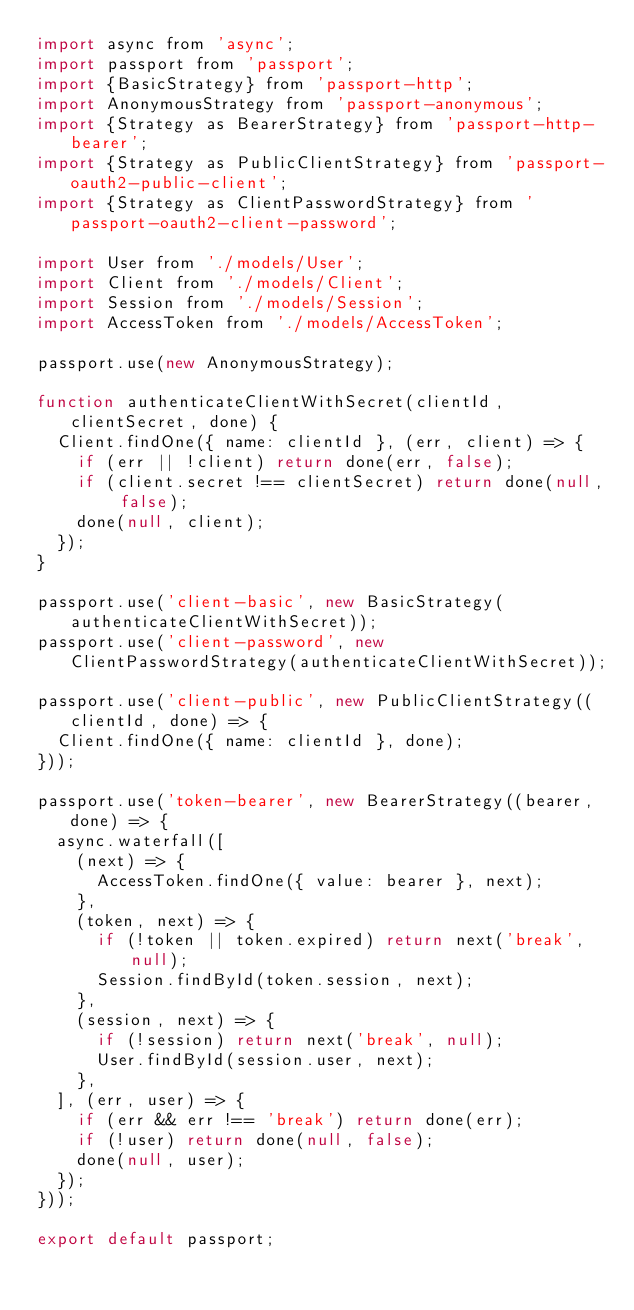Convert code to text. <code><loc_0><loc_0><loc_500><loc_500><_JavaScript_>import async from 'async';
import passport from 'passport';
import {BasicStrategy} from 'passport-http';
import AnonymousStrategy from 'passport-anonymous';
import {Strategy as BearerStrategy} from 'passport-http-bearer';
import {Strategy as PublicClientStrategy} from 'passport-oauth2-public-client';
import {Strategy as ClientPasswordStrategy} from 'passport-oauth2-client-password';

import User from './models/User';
import Client from './models/Client';
import Session from './models/Session';
import AccessToken from './models/AccessToken';

passport.use(new AnonymousStrategy);

function authenticateClientWithSecret(clientId, clientSecret, done) {
	Client.findOne({ name: clientId }, (err, client) => {
		if (err || !client) return done(err, false);
		if (client.secret !== clientSecret) return done(null, false);
		done(null, client);
	});
}

passport.use('client-basic', new BasicStrategy(authenticateClientWithSecret));
passport.use('client-password', new ClientPasswordStrategy(authenticateClientWithSecret));

passport.use('client-public', new PublicClientStrategy((clientId, done) => {
	Client.findOne({ name: clientId }, done);
}));

passport.use('token-bearer', new BearerStrategy((bearer, done) => {
	async.waterfall([
		(next) => {
			AccessToken.findOne({ value: bearer }, next);
		},
		(token, next) => {
			if (!token || token.expired) return next('break', null);
			Session.findById(token.session, next);
		},
		(session, next) => {
			if (!session) return next('break', null);
			User.findById(session.user, next);
		},
	], (err, user) => {
		if (err && err !== 'break') return done(err);
		if (!user) return done(null, false);
		done(null, user);
	});
}));

export default passport;
</code> 